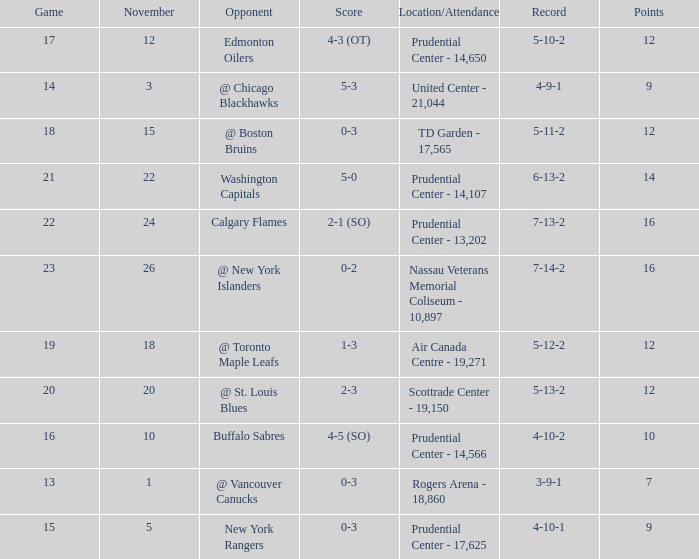What is the maximum number of points? 16.0. 